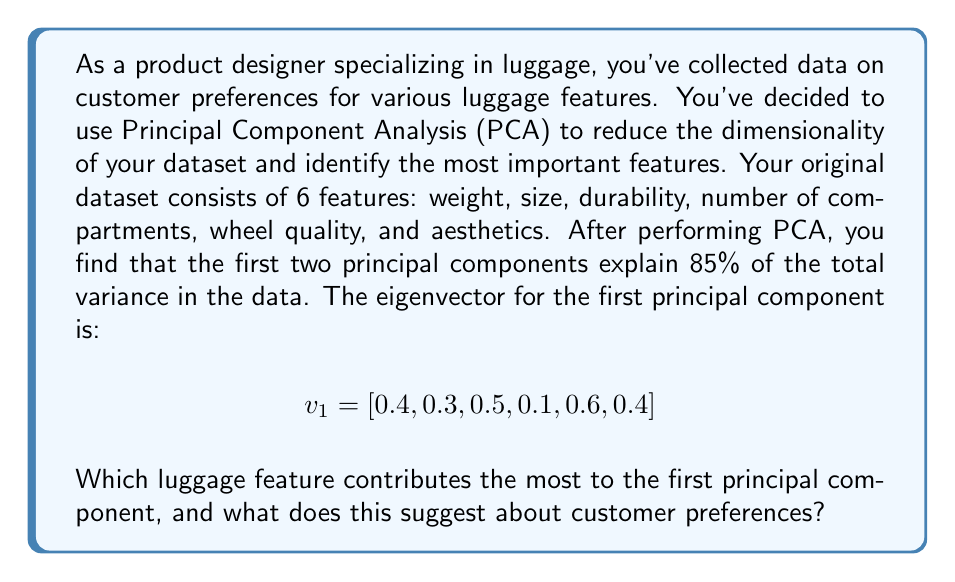Show me your answer to this math problem. To determine which feature contributes the most to the first principal component, we need to analyze the eigenvector $v_1$. The eigenvector represents the weights or loadings of each original feature in the new principal component.

The eigenvector is given as:

$$v_1 = [0.4, 0.3, 0.5, 0.1, 0.6, 0.4]$$

Each value in this vector corresponds to a feature in the original dataset:

1. Weight: 0.4
2. Size: 0.3
3. Durability: 0.5
4. Number of compartments: 0.1
5. Wheel quality: 0.6
6. Aesthetics: 0.4

To find the feature that contributes the most, we need to identify the largest absolute value in the eigenvector. In this case, the largest value is 0.6, which corresponds to wheel quality.

This result suggests that wheel quality is the most influential feature in the first principal component. Since the first principal component typically represents the direction of maximum variance in the data, we can infer that wheel quality is a crucial factor in customer preferences for luggage.

The high contribution of wheel quality to the first principal component indicates that:

1. There is significant variation in customer preferences regarding wheel quality.
2. Wheel quality is likely a key differentiating factor among luggage options.
3. Customers place high importance on the quality of wheels when choosing luggage.

This information is valuable for a product designer, as it suggests that focusing on improving wheel quality could have a significant impact on customer satisfaction and product differentiation in the luggage market.
Answer: Wheel quality contributes the most to the first principal component, with a loading of 0.6. This suggests that wheel quality is a crucial factor in customer preferences for luggage, indicating that customers highly value and differentiate products based on the quality of their wheels. 